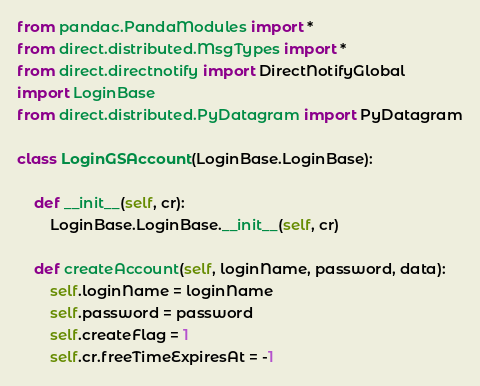<code> <loc_0><loc_0><loc_500><loc_500><_Python_>from pandac.PandaModules import *
from direct.distributed.MsgTypes import *
from direct.directnotify import DirectNotifyGlobal
import LoginBase
from direct.distributed.PyDatagram import PyDatagram

class LoginGSAccount(LoginBase.LoginBase):

    def __init__(self, cr):
        LoginBase.LoginBase.__init__(self, cr)

    def createAccount(self, loginName, password, data):
        self.loginName = loginName
        self.password = password
        self.createFlag = 1
        self.cr.freeTimeExpiresAt = -1</code> 